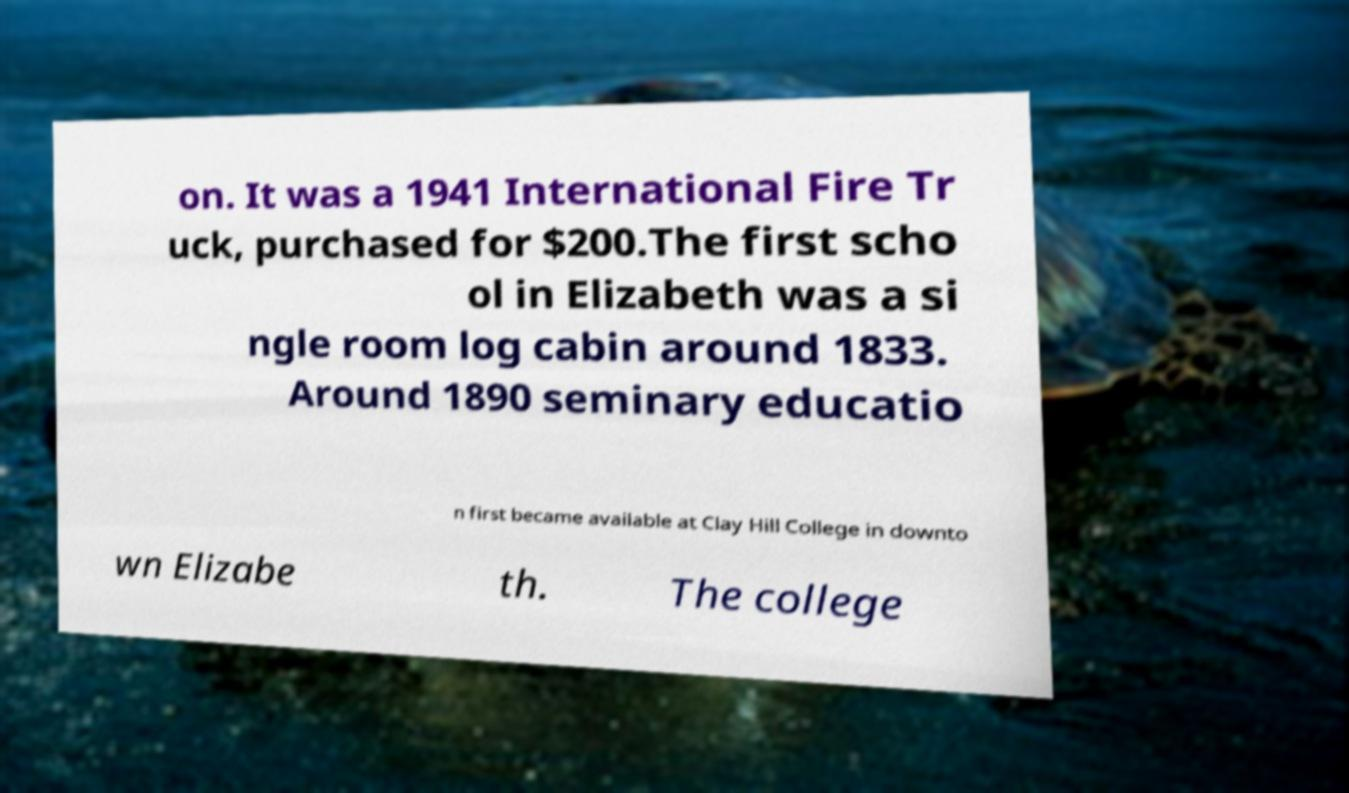What messages or text are displayed in this image? I need them in a readable, typed format. on. It was a 1941 International Fire Tr uck, purchased for $200.The first scho ol in Elizabeth was a si ngle room log cabin around 1833. Around 1890 seminary educatio n first became available at Clay Hill College in downto wn Elizabe th. The college 